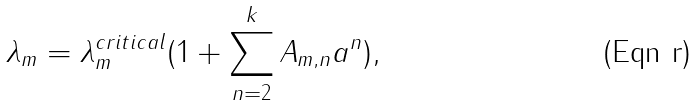Convert formula to latex. <formula><loc_0><loc_0><loc_500><loc_500>\lambda _ { m } = \lambda _ { m } ^ { c r i t i c a l } ( 1 + \sum _ { n = 2 } ^ { k } A _ { m , n } a ^ { n } ) ,</formula> 